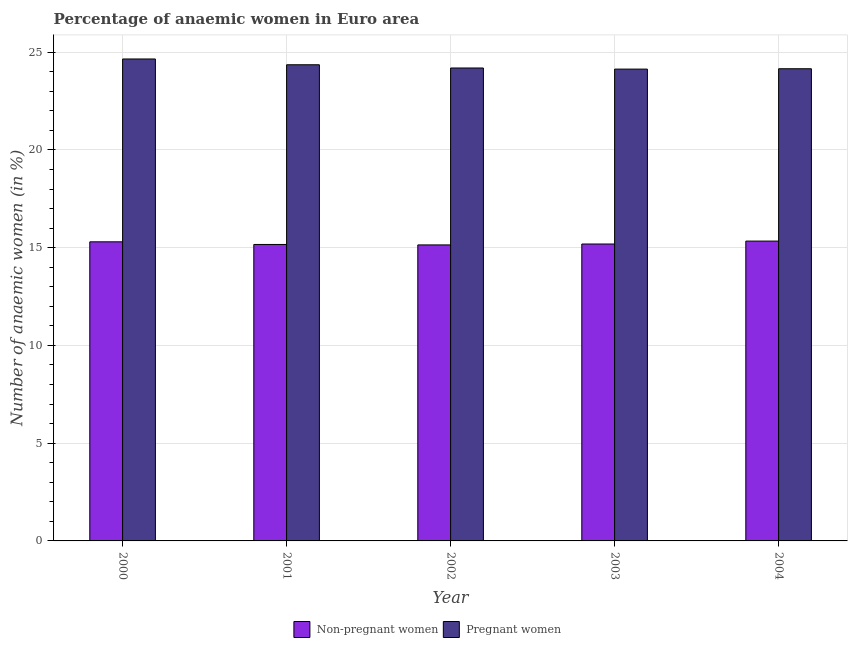How many different coloured bars are there?
Your answer should be compact. 2. How many groups of bars are there?
Keep it short and to the point. 5. Are the number of bars per tick equal to the number of legend labels?
Ensure brevity in your answer.  Yes. What is the label of the 4th group of bars from the left?
Provide a short and direct response. 2003. In how many cases, is the number of bars for a given year not equal to the number of legend labels?
Your response must be concise. 0. What is the percentage of pregnant anaemic women in 2001?
Make the answer very short. 24.36. Across all years, what is the maximum percentage of pregnant anaemic women?
Your answer should be compact. 24.65. Across all years, what is the minimum percentage of pregnant anaemic women?
Your answer should be compact. 24.13. In which year was the percentage of pregnant anaemic women maximum?
Provide a succinct answer. 2000. What is the total percentage of pregnant anaemic women in the graph?
Give a very brief answer. 121.49. What is the difference between the percentage of non-pregnant anaemic women in 2003 and that in 2004?
Your answer should be compact. -0.15. What is the difference between the percentage of non-pregnant anaemic women in 2000 and the percentage of pregnant anaemic women in 2001?
Make the answer very short. 0.14. What is the average percentage of non-pregnant anaemic women per year?
Keep it short and to the point. 15.23. In how many years, is the percentage of pregnant anaemic women greater than 7 %?
Provide a short and direct response. 5. What is the ratio of the percentage of non-pregnant anaemic women in 2000 to that in 2003?
Your answer should be compact. 1.01. Is the percentage of pregnant anaemic women in 2000 less than that in 2003?
Give a very brief answer. No. Is the difference between the percentage of pregnant anaemic women in 2003 and 2004 greater than the difference between the percentage of non-pregnant anaemic women in 2003 and 2004?
Make the answer very short. No. What is the difference between the highest and the second highest percentage of non-pregnant anaemic women?
Give a very brief answer. 0.04. What is the difference between the highest and the lowest percentage of non-pregnant anaemic women?
Your answer should be compact. 0.2. In how many years, is the percentage of non-pregnant anaemic women greater than the average percentage of non-pregnant anaemic women taken over all years?
Your response must be concise. 2. What does the 1st bar from the left in 2001 represents?
Make the answer very short. Non-pregnant women. What does the 2nd bar from the right in 2000 represents?
Give a very brief answer. Non-pregnant women. How many bars are there?
Make the answer very short. 10. Are all the bars in the graph horizontal?
Ensure brevity in your answer.  No. Are the values on the major ticks of Y-axis written in scientific E-notation?
Offer a very short reply. No. Does the graph contain grids?
Your response must be concise. Yes. How many legend labels are there?
Your response must be concise. 2. What is the title of the graph?
Provide a succinct answer. Percentage of anaemic women in Euro area. What is the label or title of the Y-axis?
Make the answer very short. Number of anaemic women (in %). What is the Number of anaemic women (in %) in Non-pregnant women in 2000?
Provide a succinct answer. 15.3. What is the Number of anaemic women (in %) in Pregnant women in 2000?
Your answer should be very brief. 24.65. What is the Number of anaemic women (in %) of Non-pregnant women in 2001?
Offer a terse response. 15.16. What is the Number of anaemic women (in %) in Pregnant women in 2001?
Your answer should be very brief. 24.36. What is the Number of anaemic women (in %) of Non-pregnant women in 2002?
Give a very brief answer. 15.14. What is the Number of anaemic women (in %) of Pregnant women in 2002?
Give a very brief answer. 24.19. What is the Number of anaemic women (in %) in Non-pregnant women in 2003?
Make the answer very short. 15.19. What is the Number of anaemic women (in %) in Pregnant women in 2003?
Provide a succinct answer. 24.13. What is the Number of anaemic women (in %) in Non-pregnant women in 2004?
Keep it short and to the point. 15.34. What is the Number of anaemic women (in %) of Pregnant women in 2004?
Offer a terse response. 24.15. Across all years, what is the maximum Number of anaemic women (in %) in Non-pregnant women?
Offer a very short reply. 15.34. Across all years, what is the maximum Number of anaemic women (in %) in Pregnant women?
Your answer should be compact. 24.65. Across all years, what is the minimum Number of anaemic women (in %) in Non-pregnant women?
Offer a very short reply. 15.14. Across all years, what is the minimum Number of anaemic women (in %) of Pregnant women?
Keep it short and to the point. 24.13. What is the total Number of anaemic women (in %) of Non-pregnant women in the graph?
Offer a very short reply. 76.13. What is the total Number of anaemic women (in %) in Pregnant women in the graph?
Provide a short and direct response. 121.49. What is the difference between the Number of anaemic women (in %) of Non-pregnant women in 2000 and that in 2001?
Your response must be concise. 0.14. What is the difference between the Number of anaemic women (in %) in Pregnant women in 2000 and that in 2001?
Your answer should be compact. 0.3. What is the difference between the Number of anaemic women (in %) in Non-pregnant women in 2000 and that in 2002?
Your answer should be compact. 0.16. What is the difference between the Number of anaemic women (in %) in Pregnant women in 2000 and that in 2002?
Give a very brief answer. 0.46. What is the difference between the Number of anaemic women (in %) of Non-pregnant women in 2000 and that in 2003?
Give a very brief answer. 0.11. What is the difference between the Number of anaemic women (in %) in Pregnant women in 2000 and that in 2003?
Ensure brevity in your answer.  0.52. What is the difference between the Number of anaemic women (in %) in Non-pregnant women in 2000 and that in 2004?
Make the answer very short. -0.04. What is the difference between the Number of anaemic women (in %) in Pregnant women in 2000 and that in 2004?
Ensure brevity in your answer.  0.5. What is the difference between the Number of anaemic women (in %) of Non-pregnant women in 2001 and that in 2002?
Make the answer very short. 0.02. What is the difference between the Number of anaemic women (in %) in Pregnant women in 2001 and that in 2002?
Keep it short and to the point. 0.17. What is the difference between the Number of anaemic women (in %) in Non-pregnant women in 2001 and that in 2003?
Keep it short and to the point. -0.02. What is the difference between the Number of anaemic women (in %) in Pregnant women in 2001 and that in 2003?
Your answer should be compact. 0.22. What is the difference between the Number of anaemic women (in %) of Non-pregnant women in 2001 and that in 2004?
Your response must be concise. -0.17. What is the difference between the Number of anaemic women (in %) of Pregnant women in 2001 and that in 2004?
Your answer should be very brief. 0.2. What is the difference between the Number of anaemic women (in %) in Non-pregnant women in 2002 and that in 2003?
Give a very brief answer. -0.05. What is the difference between the Number of anaemic women (in %) of Pregnant women in 2002 and that in 2003?
Offer a very short reply. 0.06. What is the difference between the Number of anaemic women (in %) in Non-pregnant women in 2002 and that in 2004?
Offer a terse response. -0.2. What is the difference between the Number of anaemic women (in %) in Pregnant women in 2002 and that in 2004?
Make the answer very short. 0.04. What is the difference between the Number of anaemic women (in %) in Non-pregnant women in 2003 and that in 2004?
Offer a very short reply. -0.15. What is the difference between the Number of anaemic women (in %) in Pregnant women in 2003 and that in 2004?
Ensure brevity in your answer.  -0.02. What is the difference between the Number of anaemic women (in %) in Non-pregnant women in 2000 and the Number of anaemic women (in %) in Pregnant women in 2001?
Offer a very short reply. -9.06. What is the difference between the Number of anaemic women (in %) of Non-pregnant women in 2000 and the Number of anaemic women (in %) of Pregnant women in 2002?
Offer a terse response. -8.89. What is the difference between the Number of anaemic women (in %) in Non-pregnant women in 2000 and the Number of anaemic women (in %) in Pregnant women in 2003?
Ensure brevity in your answer.  -8.83. What is the difference between the Number of anaemic women (in %) of Non-pregnant women in 2000 and the Number of anaemic women (in %) of Pregnant women in 2004?
Provide a short and direct response. -8.85. What is the difference between the Number of anaemic women (in %) of Non-pregnant women in 2001 and the Number of anaemic women (in %) of Pregnant women in 2002?
Provide a succinct answer. -9.03. What is the difference between the Number of anaemic women (in %) in Non-pregnant women in 2001 and the Number of anaemic women (in %) in Pregnant women in 2003?
Provide a succinct answer. -8.97. What is the difference between the Number of anaemic women (in %) of Non-pregnant women in 2001 and the Number of anaemic women (in %) of Pregnant women in 2004?
Your answer should be very brief. -8.99. What is the difference between the Number of anaemic women (in %) in Non-pregnant women in 2002 and the Number of anaemic women (in %) in Pregnant women in 2003?
Provide a succinct answer. -8.99. What is the difference between the Number of anaemic women (in %) of Non-pregnant women in 2002 and the Number of anaemic women (in %) of Pregnant women in 2004?
Ensure brevity in your answer.  -9.01. What is the difference between the Number of anaemic women (in %) in Non-pregnant women in 2003 and the Number of anaemic women (in %) in Pregnant women in 2004?
Your answer should be very brief. -8.97. What is the average Number of anaemic women (in %) in Non-pregnant women per year?
Make the answer very short. 15.23. What is the average Number of anaemic women (in %) of Pregnant women per year?
Ensure brevity in your answer.  24.3. In the year 2000, what is the difference between the Number of anaemic women (in %) in Non-pregnant women and Number of anaemic women (in %) in Pregnant women?
Provide a succinct answer. -9.35. In the year 2001, what is the difference between the Number of anaemic women (in %) in Non-pregnant women and Number of anaemic women (in %) in Pregnant women?
Offer a terse response. -9.19. In the year 2002, what is the difference between the Number of anaemic women (in %) in Non-pregnant women and Number of anaemic women (in %) in Pregnant women?
Make the answer very short. -9.05. In the year 2003, what is the difference between the Number of anaemic women (in %) of Non-pregnant women and Number of anaemic women (in %) of Pregnant women?
Provide a short and direct response. -8.95. In the year 2004, what is the difference between the Number of anaemic women (in %) in Non-pregnant women and Number of anaemic women (in %) in Pregnant women?
Ensure brevity in your answer.  -8.82. What is the ratio of the Number of anaemic women (in %) in Non-pregnant women in 2000 to that in 2001?
Your answer should be very brief. 1.01. What is the ratio of the Number of anaemic women (in %) in Pregnant women in 2000 to that in 2001?
Provide a short and direct response. 1.01. What is the ratio of the Number of anaemic women (in %) in Non-pregnant women in 2000 to that in 2002?
Your answer should be very brief. 1.01. What is the ratio of the Number of anaemic women (in %) in Pregnant women in 2000 to that in 2002?
Make the answer very short. 1.02. What is the ratio of the Number of anaemic women (in %) in Non-pregnant women in 2000 to that in 2003?
Offer a very short reply. 1.01. What is the ratio of the Number of anaemic women (in %) in Pregnant women in 2000 to that in 2003?
Ensure brevity in your answer.  1.02. What is the ratio of the Number of anaemic women (in %) in Pregnant women in 2000 to that in 2004?
Your answer should be very brief. 1.02. What is the ratio of the Number of anaemic women (in %) in Non-pregnant women in 2001 to that in 2002?
Offer a very short reply. 1. What is the ratio of the Number of anaemic women (in %) in Pregnant women in 2001 to that in 2003?
Provide a short and direct response. 1.01. What is the ratio of the Number of anaemic women (in %) of Non-pregnant women in 2001 to that in 2004?
Your response must be concise. 0.99. What is the ratio of the Number of anaemic women (in %) in Pregnant women in 2001 to that in 2004?
Provide a succinct answer. 1.01. What is the ratio of the Number of anaemic women (in %) of Non-pregnant women in 2002 to that in 2004?
Give a very brief answer. 0.99. What is the ratio of the Number of anaemic women (in %) in Non-pregnant women in 2003 to that in 2004?
Your response must be concise. 0.99. What is the ratio of the Number of anaemic women (in %) of Pregnant women in 2003 to that in 2004?
Offer a terse response. 1. What is the difference between the highest and the second highest Number of anaemic women (in %) in Non-pregnant women?
Offer a terse response. 0.04. What is the difference between the highest and the second highest Number of anaemic women (in %) in Pregnant women?
Your answer should be compact. 0.3. What is the difference between the highest and the lowest Number of anaemic women (in %) in Non-pregnant women?
Keep it short and to the point. 0.2. What is the difference between the highest and the lowest Number of anaemic women (in %) in Pregnant women?
Make the answer very short. 0.52. 